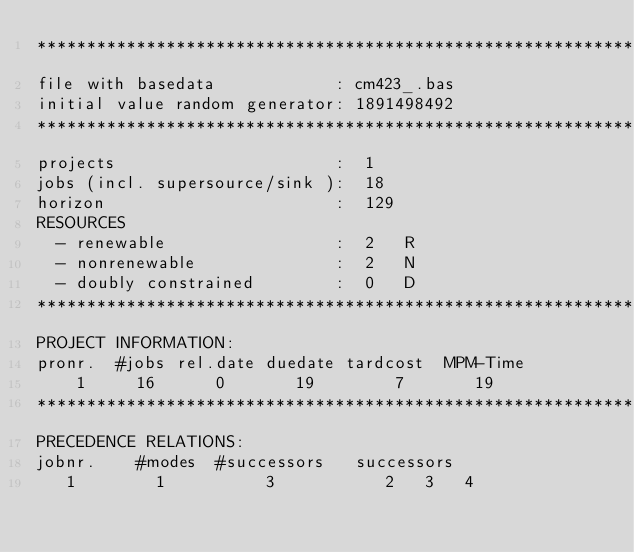Convert code to text. <code><loc_0><loc_0><loc_500><loc_500><_ObjectiveC_>************************************************************************
file with basedata            : cm423_.bas
initial value random generator: 1891498492
************************************************************************
projects                      :  1
jobs (incl. supersource/sink ):  18
horizon                       :  129
RESOURCES
  - renewable                 :  2   R
  - nonrenewable              :  2   N
  - doubly constrained        :  0   D
************************************************************************
PROJECT INFORMATION:
pronr.  #jobs rel.date duedate tardcost  MPM-Time
    1     16      0       19        7       19
************************************************************************
PRECEDENCE RELATIONS:
jobnr.    #modes  #successors   successors
   1        1          3           2   3   4</code> 